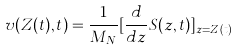<formula> <loc_0><loc_0><loc_500><loc_500>v ( Z ( t ) , t ) = \frac { 1 } { M _ { N } } [ \frac { d } { d z } S ( z , t ) ] _ { z = Z ( t ) }</formula> 